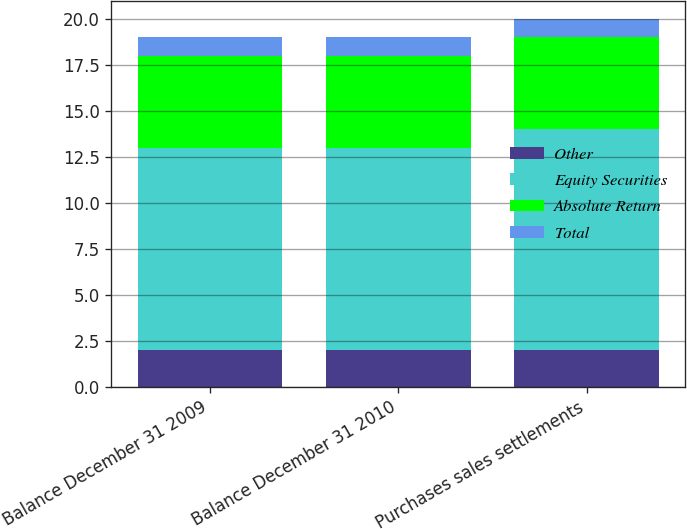Convert chart. <chart><loc_0><loc_0><loc_500><loc_500><stacked_bar_chart><ecel><fcel>Balance December 31 2009<fcel>Balance December 31 2010<fcel>Purchases sales settlements<nl><fcel>Other<fcel>2<fcel>2<fcel>2<nl><fcel>Equity Securities<fcel>11<fcel>11<fcel>12<nl><fcel>Absolute Return<fcel>5<fcel>5<fcel>5<nl><fcel>Total<fcel>1<fcel>1<fcel>1<nl></chart> 